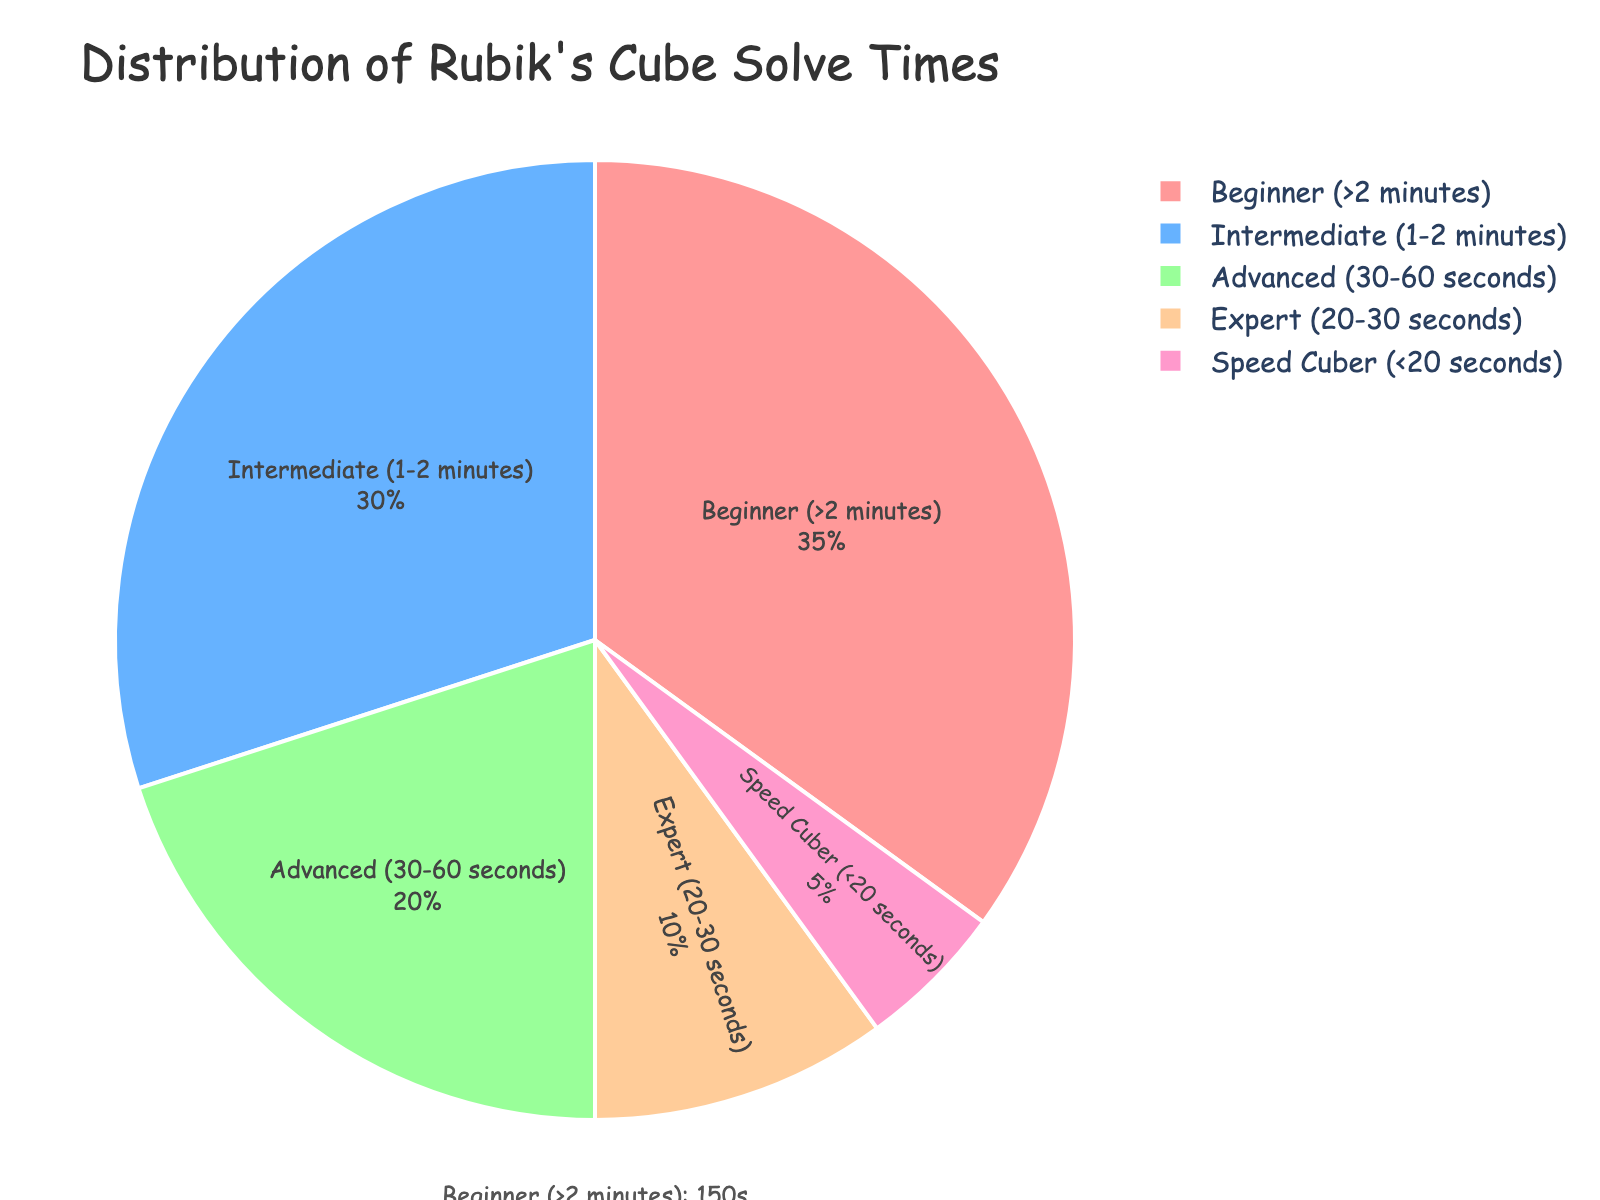What's the most common skill level for Rubik's Cube solve times? The most common skill level is determined by the largest percentage slice in the pie chart. Here, it's the "Beginner (>2 minutes)" category at 35%.
Answer: Beginner (>2 minutes) Which skill level has the fastest average solve time? The fastest average solve time corresponds to the smallest average time value. From the chart, "Speed Cuber (<20 seconds)" at 15 seconds is the fastest.
Answer: Speed Cuber (<20 seconds) What is the total percentage of solvers who are either Advanced or Expert? To get the total percentage, add the percentages of Advanced and Expert skill levels. Advanced is 20% and Expert is 10%, so 20% + 10% = 30%.
Answer: 30% Which skill level has a larger percentage, Intermediate or Expert? Compare the percentages of Intermediate and Expert. Intermediate is at 30%, while Expert is at 10%. 30% is greater than 10%.
Answer: Intermediate By how many seconds is the Intermediate average solve time larger than the Expert average solve time? Subtract the average solve time of the Expert level from the Intermediate level. Intermediate is 90s and Expert is 25s, so 90s - 25s = 65s.
Answer: 65 seconds What is the average solve time for a skill level categorized as Advanced? The average solve time for the Advanced skill level is listed directly in the data. From the chart, it is 45 seconds.
Answer: 45 seconds Which skill level is represented by the color pink? Observe the color key or legend in the pie chart. The pink slice represents the "Beginner (>2 minutes)" skill level.
Answer: Beginner (>2 minutes) How much smaller is the Speed Cuber percentage compared to the Beginner percentage? Subtract the Speed Cuber percentage from the Beginner percentage. Beginner is at 35%, and Speed Cuber is at 5%. So, 35% - 5% = 30%.
Answer: 30% What is the total percentage of solvers who solve in less than a minute? Add the percentages of Advanced (30-60 seconds), Expert (20-30 seconds), and Speed Cuber (<20 seconds). That's 20% + 10% + 5% = 35%.
Answer: 35% Which skill level’s average solve time is one minute and thirty seconds? Convert one minute thirty seconds to seconds (1*60 + 30 = 90s), and find the matching skill level. From the chart, the Intermediate level has an average solve time of 90 seconds.
Answer: Intermediate 